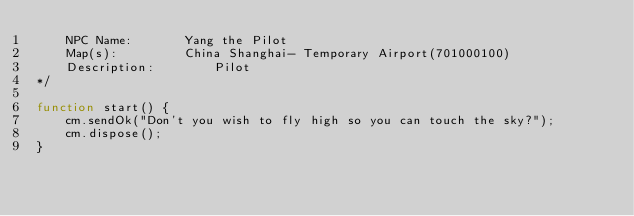<code> <loc_0><loc_0><loc_500><loc_500><_JavaScript_>	NPC Name: 		Yang the Pilot
	Map(s): 		China Shanghai- Temporary Airport(701000100)
	Description: 		Pilot
*/

function start() {
    cm.sendOk("Don't you wish to fly high so you can touch the sky?");
    cm.dispose();
}</code> 